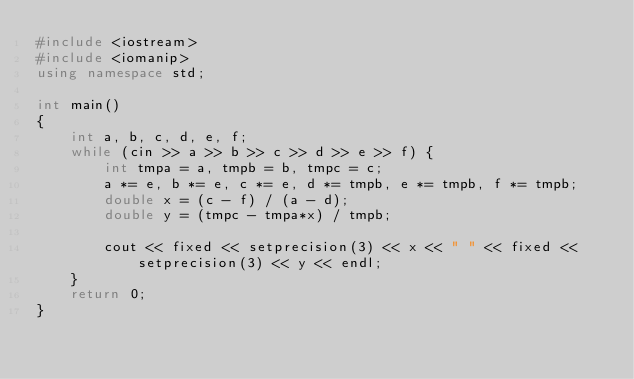Convert code to text. <code><loc_0><loc_0><loc_500><loc_500><_C++_>#include <iostream>
#include <iomanip>
using namespace std;

int main()
{
	int a, b, c, d, e, f;
	while (cin >> a >> b >> c >> d >> e >> f) {
		int tmpa = a, tmpb = b, tmpc = c;
		a *= e, b *= e, c *= e, d *= tmpb, e *= tmpb, f *= tmpb;
		double x = (c - f) / (a - d);
		double y = (tmpc - tmpa*x) / tmpb;

		cout << fixed << setprecision(3) << x << " " << fixed << setprecision(3) << y << endl;
	}
	return 0;
}</code> 